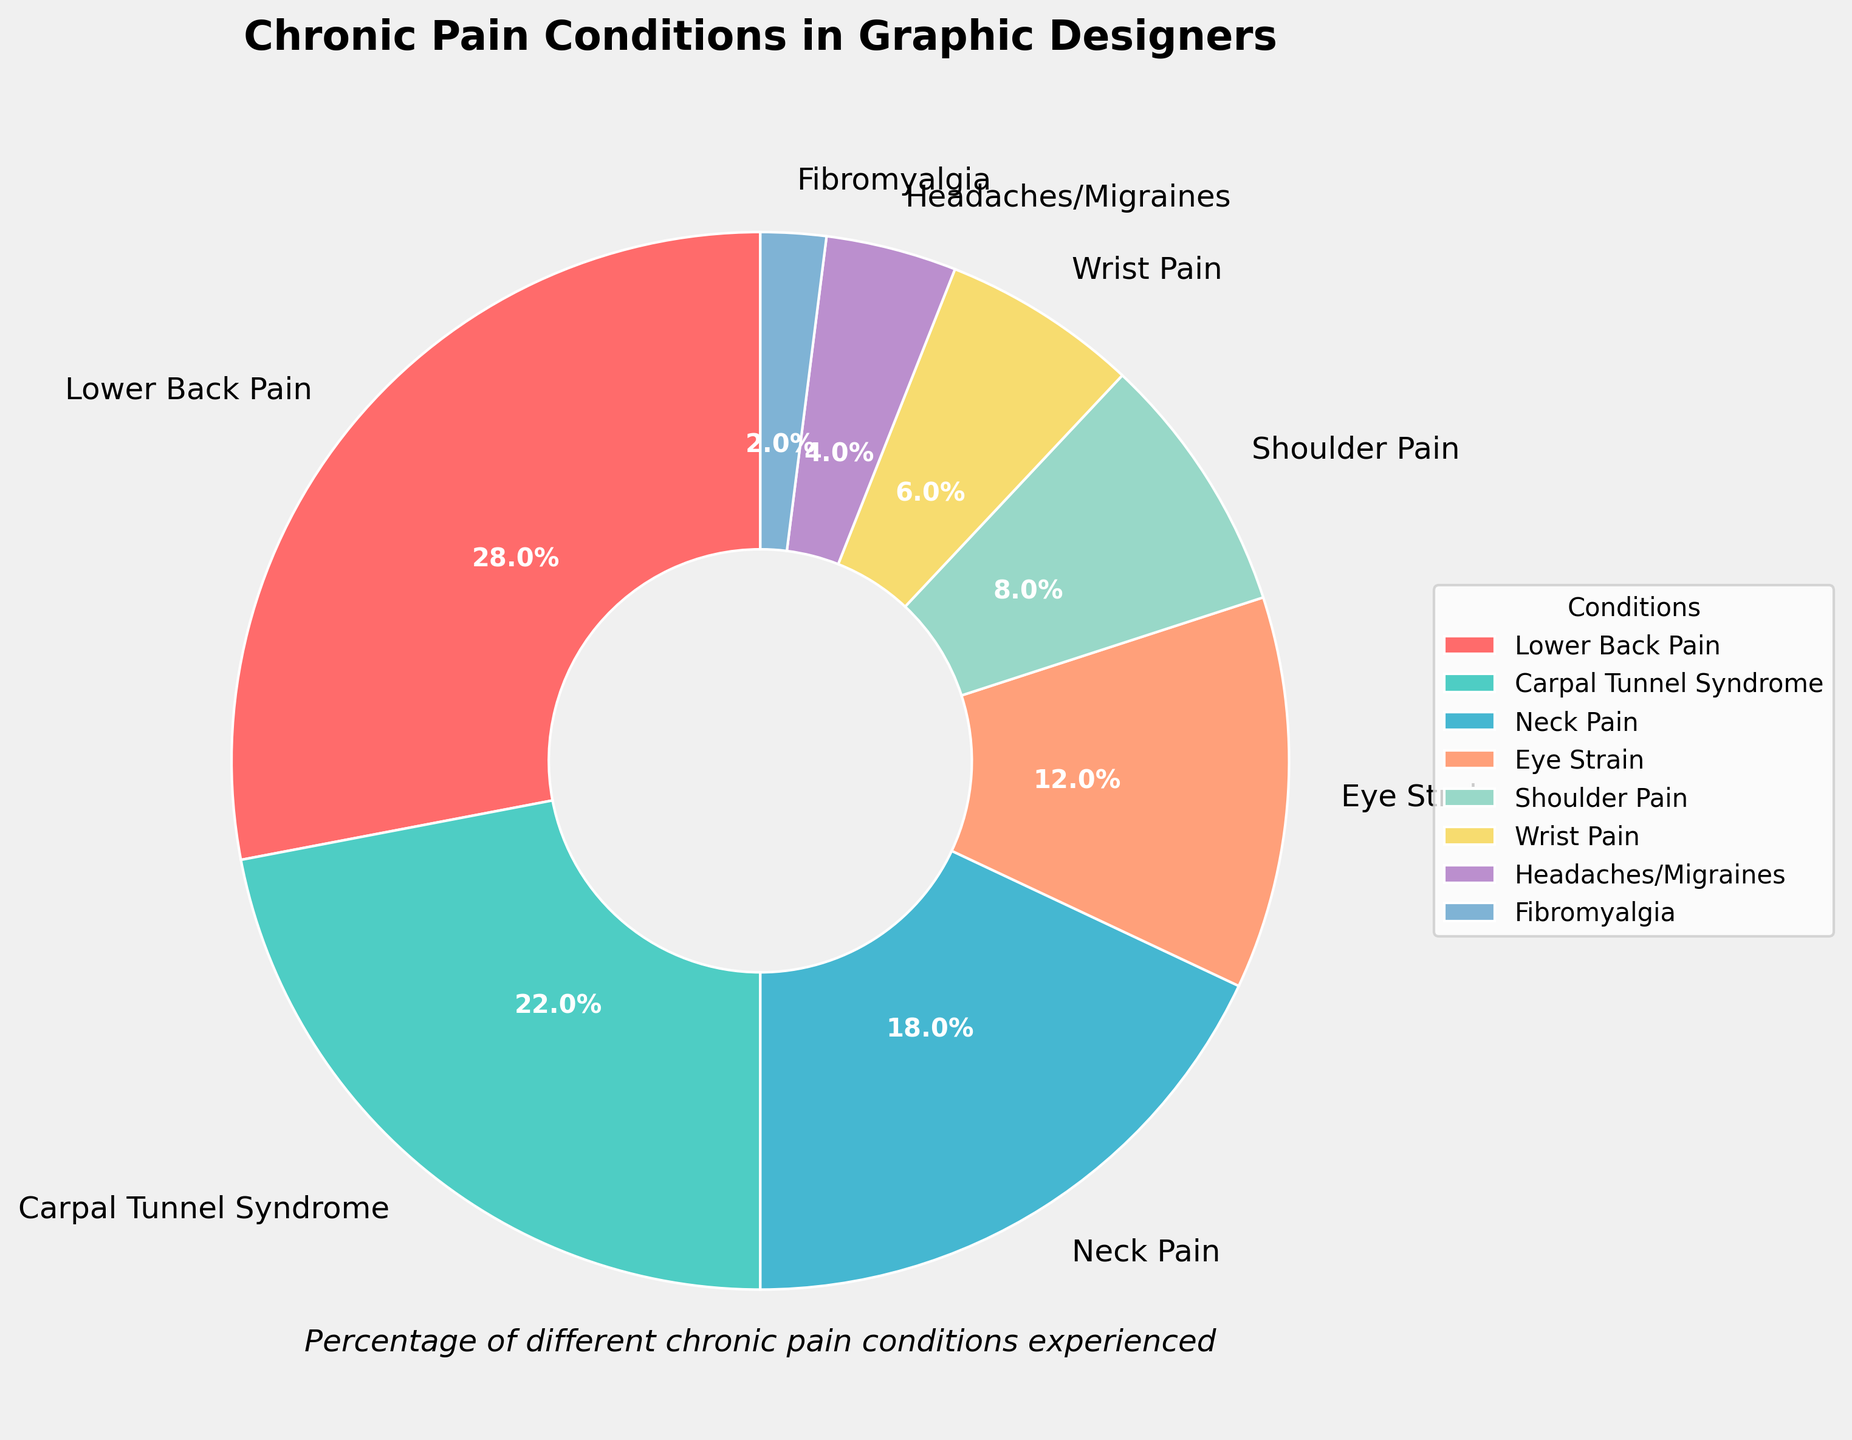What is the most common chronic pain condition experienced by graphic designers? The most visually significant wedge in the pie chart represents the most common condition. Lower Back Pain has the largest wedge and is labeled with the highest percentage (28%).
Answer: Lower Back Pain Which condition affects more graphic designers: Wrist Pain or Eye Strain? Compare the sizes of the wedges labeled Wrist Pain and Eye Strain. Eye Strain has a wedge labeled with a higher percentage (12%) than Wrist Pain (6%).
Answer: Eye Strain What is the combined percentage of graphic designers experiencing Neck Pain and Shoulder Pain? Sum the percentages of Neck Pain (18%) and Shoulder Pain (8%). 18 + 8 = 26.
Answer: 26% Which condition has the second lowest percentage after Fibromyalgia? Inspect the labels on the wedges for the smallest percentages. Fibromyalgia is the lowest with 2%, and Headaches/Migraines follows with 4%.
Answer: Headaches/Migraines How much larger is the percentage of Carpal Tunnel Syndrome compared to Fibromyalgia? Subtract the percentage of Fibromyalgia (2%) from Carpal Tunnel Syndrome (22%). 22 - 2 = 20.
Answer: 20% How many conditions have a percentage less than 10%? Count the wedges labeled with percentages below 10: Shoulder Pain (8%), Wrist Pain (6%), Headaches/Migraines (4%), and Fibromyalgia (2%).
Answer: 4 What is the difference in percentage between the most common and the least common chronic pain conditions? Subtract the percentage of Fibromyalgia (2%) from Lower Back Pain (28%). 28 - 2 = 26.
Answer: 26% Which color represents Carpal Tunnel Syndrome in the pie chart? Identify the color of the wedge labeled Carpal Tunnel Syndrome by visual inspection. It is assigned the second color in the custom color palette.
Answer: Green 